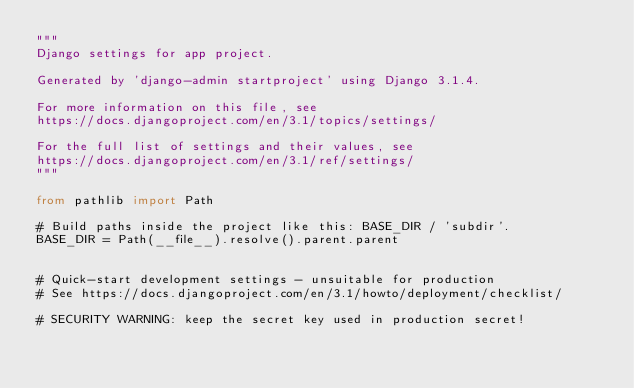<code> <loc_0><loc_0><loc_500><loc_500><_Python_>"""
Django settings for app project.

Generated by 'django-admin startproject' using Django 3.1.4.

For more information on this file, see
https://docs.djangoproject.com/en/3.1/topics/settings/

For the full list of settings and their values, see
https://docs.djangoproject.com/en/3.1/ref/settings/
"""

from pathlib import Path

# Build paths inside the project like this: BASE_DIR / 'subdir'.
BASE_DIR = Path(__file__).resolve().parent.parent


# Quick-start development settings - unsuitable for production
# See https://docs.djangoproject.com/en/3.1/howto/deployment/checklist/

# SECURITY WARNING: keep the secret key used in production secret!</code> 